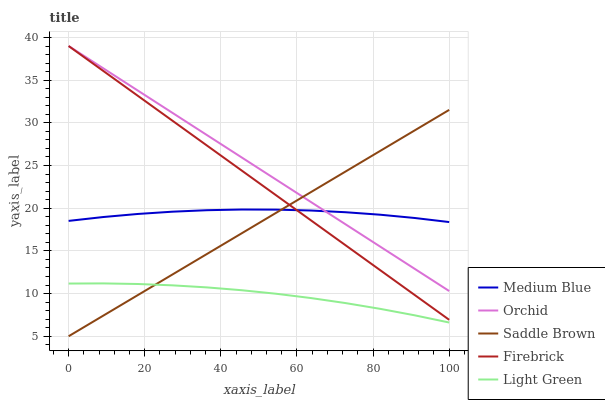Does Light Green have the minimum area under the curve?
Answer yes or no. Yes. Does Orchid have the maximum area under the curve?
Answer yes or no. Yes. Does Medium Blue have the minimum area under the curve?
Answer yes or no. No. Does Medium Blue have the maximum area under the curve?
Answer yes or no. No. Is Saddle Brown the smoothest?
Answer yes or no. Yes. Is Medium Blue the roughest?
Answer yes or no. Yes. Is Medium Blue the smoothest?
Answer yes or no. No. Is Saddle Brown the roughest?
Answer yes or no. No. Does Saddle Brown have the lowest value?
Answer yes or no. Yes. Does Medium Blue have the lowest value?
Answer yes or no. No. Does Orchid have the highest value?
Answer yes or no. Yes. Does Medium Blue have the highest value?
Answer yes or no. No. Is Light Green less than Medium Blue?
Answer yes or no. Yes. Is Firebrick greater than Light Green?
Answer yes or no. Yes. Does Firebrick intersect Orchid?
Answer yes or no. Yes. Is Firebrick less than Orchid?
Answer yes or no. No. Is Firebrick greater than Orchid?
Answer yes or no. No. Does Light Green intersect Medium Blue?
Answer yes or no. No. 